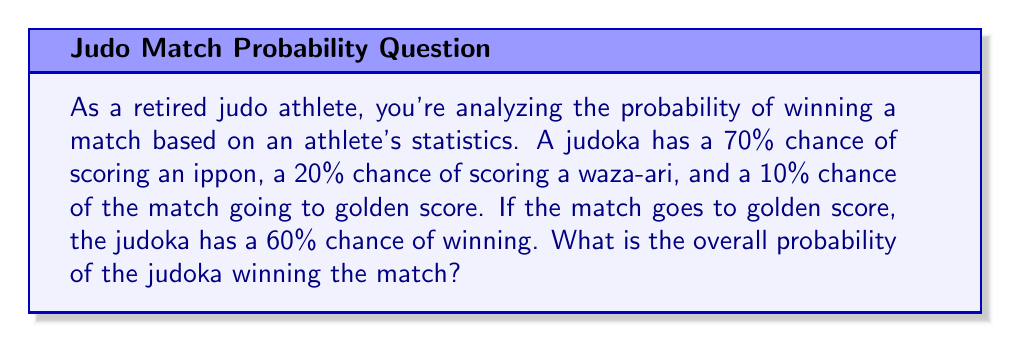Give your solution to this math problem. Let's approach this step-by-step:

1) First, let's define our events:
   A: Winning by ippon
   B: Winning by waza-ari
   C: Match goes to golden score
   D: Winning in golden score

2) We're given these probabilities:
   $P(A) = 0.70$
   $P(B) = 0.20$
   $P(C) = 0.10$
   $P(D|C) = 0.60$ (probability of winning given that the match goes to golden score)

3) The total probability of winning is the sum of the probabilities of winning in each scenario:
   $P(\text{Win}) = P(A) + P(B) + P(C) \cdot P(D|C)$

4) Substituting the values:
   $P(\text{Win}) = 0.70 + 0.20 + 0.10 \cdot 0.60$

5) Calculating:
   $P(\text{Win}) = 0.70 + 0.20 + 0.06$
   $P(\text{Win}) = 0.96$

6) Converting to a percentage:
   $P(\text{Win}) = 0.96 \cdot 100\% = 96\%$
Answer: 96% 